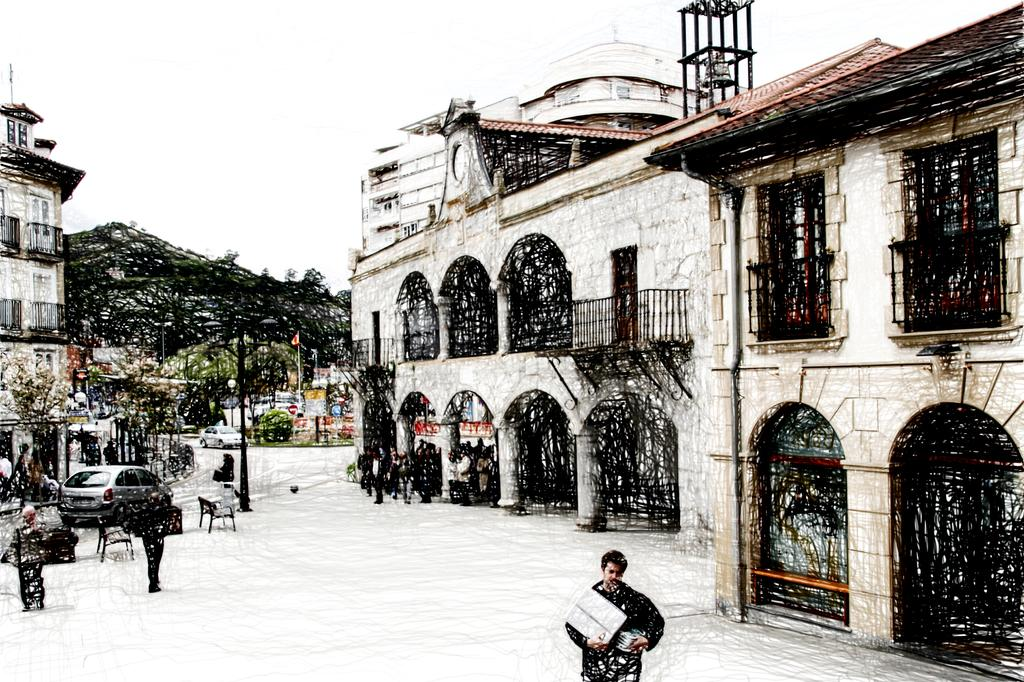What is happening in the image due to the weather? There is snowfall in the image. What are people doing in the image despite the snowfall? People are walking on the road in the image. What else can be seen moving on the road in the image? Vehicles are moving on the road in the image. What structures are present along the road in the image? There are poles, flags, and buildings in the image. What type of vegetation is visible in the image? There are trees in the image. What can be seen in the background of the image? The sky is visible in the background of the image. Can you see a woman sitting comfortably by the window in the image? There is no woman sitting by a window in the image. The image primarily focuses on the snowfall, people walking, vehicles moving, and the presence of poles, flags, buildings, trees, and the sky. 